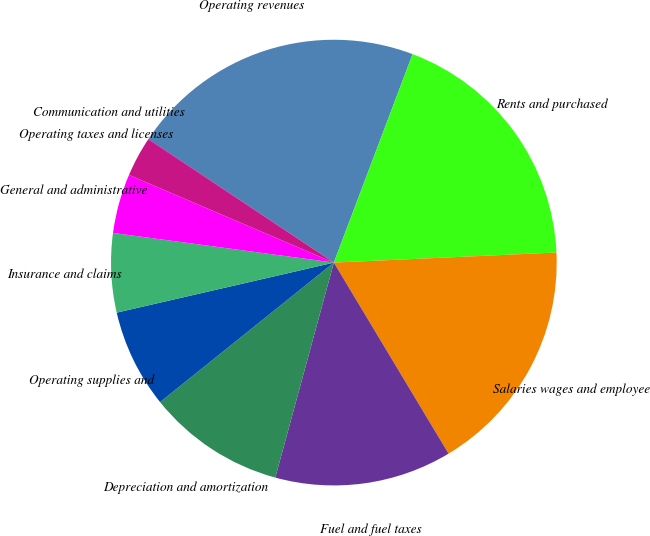Convert chart to OTSL. <chart><loc_0><loc_0><loc_500><loc_500><pie_chart><fcel>Operating revenues<fcel>Rents and purchased<fcel>Salaries wages and employee<fcel>Fuel and fuel taxes<fcel>Depreciation and amortization<fcel>Operating supplies and<fcel>Insurance and claims<fcel>General and administrative<fcel>Operating taxes and licenses<fcel>Communication and utilities<nl><fcel>21.38%<fcel>18.53%<fcel>17.11%<fcel>12.84%<fcel>10.0%<fcel>7.16%<fcel>5.73%<fcel>4.31%<fcel>2.89%<fcel>0.04%<nl></chart> 